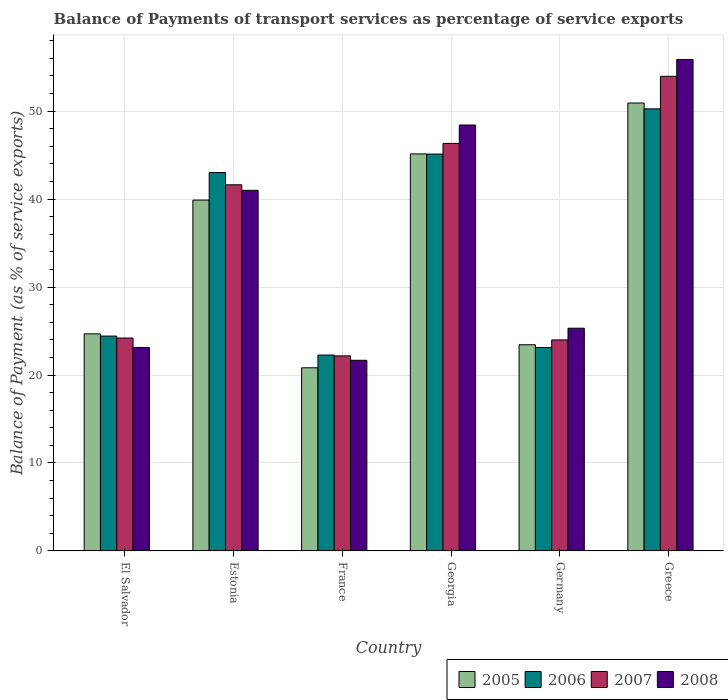How many different coloured bars are there?
Your answer should be compact. 4. Are the number of bars per tick equal to the number of legend labels?
Make the answer very short. Yes. How many bars are there on the 2nd tick from the left?
Provide a short and direct response. 4. How many bars are there on the 6th tick from the right?
Offer a terse response. 4. What is the label of the 3rd group of bars from the left?
Offer a terse response. France. What is the balance of payments of transport services in 2008 in El Salvador?
Your answer should be very brief. 23.13. Across all countries, what is the maximum balance of payments of transport services in 2008?
Provide a short and direct response. 55.87. Across all countries, what is the minimum balance of payments of transport services in 2006?
Make the answer very short. 22.27. What is the total balance of payments of transport services in 2005 in the graph?
Ensure brevity in your answer.  204.87. What is the difference between the balance of payments of transport services in 2005 in El Salvador and that in Greece?
Your response must be concise. -26.24. What is the difference between the balance of payments of transport services in 2005 in Georgia and the balance of payments of transport services in 2008 in El Salvador?
Keep it short and to the point. 22. What is the average balance of payments of transport services in 2005 per country?
Provide a short and direct response. 34.14. What is the difference between the balance of payments of transport services of/in 2006 and balance of payments of transport services of/in 2008 in Greece?
Your answer should be compact. -5.61. What is the ratio of the balance of payments of transport services in 2008 in El Salvador to that in Georgia?
Offer a very short reply. 0.48. Is the balance of payments of transport services in 2006 in El Salvador less than that in Greece?
Offer a terse response. Yes. What is the difference between the highest and the second highest balance of payments of transport services in 2005?
Offer a terse response. 5.78. What is the difference between the highest and the lowest balance of payments of transport services in 2008?
Provide a succinct answer. 34.19. Is the sum of the balance of payments of transport services in 2005 in Estonia and Greece greater than the maximum balance of payments of transport services in 2006 across all countries?
Make the answer very short. Yes. What does the 3rd bar from the left in Georgia represents?
Offer a terse response. 2007. What does the 2nd bar from the right in Georgia represents?
Offer a very short reply. 2007. Is it the case that in every country, the sum of the balance of payments of transport services in 2007 and balance of payments of transport services in 2006 is greater than the balance of payments of transport services in 2005?
Offer a terse response. Yes. How many bars are there?
Provide a succinct answer. 24. What is the difference between two consecutive major ticks on the Y-axis?
Your answer should be compact. 10. Where does the legend appear in the graph?
Keep it short and to the point. Bottom right. How many legend labels are there?
Offer a terse response. 4. What is the title of the graph?
Your answer should be very brief. Balance of Payments of transport services as percentage of service exports. Does "1997" appear as one of the legend labels in the graph?
Offer a terse response. No. What is the label or title of the Y-axis?
Provide a short and direct response. Balance of Payment (as % of service exports). What is the Balance of Payment (as % of service exports) in 2005 in El Salvador?
Offer a very short reply. 24.68. What is the Balance of Payment (as % of service exports) of 2006 in El Salvador?
Ensure brevity in your answer.  24.43. What is the Balance of Payment (as % of service exports) in 2007 in El Salvador?
Your answer should be very brief. 24.2. What is the Balance of Payment (as % of service exports) in 2008 in El Salvador?
Offer a terse response. 23.13. What is the Balance of Payment (as % of service exports) of 2005 in Estonia?
Give a very brief answer. 39.88. What is the Balance of Payment (as % of service exports) of 2006 in Estonia?
Ensure brevity in your answer.  43.01. What is the Balance of Payment (as % of service exports) in 2007 in Estonia?
Provide a succinct answer. 41.62. What is the Balance of Payment (as % of service exports) in 2008 in Estonia?
Your answer should be compact. 40.99. What is the Balance of Payment (as % of service exports) in 2005 in France?
Your answer should be very brief. 20.82. What is the Balance of Payment (as % of service exports) of 2006 in France?
Make the answer very short. 22.27. What is the Balance of Payment (as % of service exports) in 2007 in France?
Your answer should be compact. 22.18. What is the Balance of Payment (as % of service exports) in 2008 in France?
Your response must be concise. 21.67. What is the Balance of Payment (as % of service exports) in 2005 in Georgia?
Your answer should be compact. 45.13. What is the Balance of Payment (as % of service exports) of 2006 in Georgia?
Your response must be concise. 45.11. What is the Balance of Payment (as % of service exports) in 2007 in Georgia?
Ensure brevity in your answer.  46.33. What is the Balance of Payment (as % of service exports) in 2008 in Georgia?
Your response must be concise. 48.42. What is the Balance of Payment (as % of service exports) of 2005 in Germany?
Provide a short and direct response. 23.44. What is the Balance of Payment (as % of service exports) of 2006 in Germany?
Offer a very short reply. 23.13. What is the Balance of Payment (as % of service exports) in 2007 in Germany?
Offer a terse response. 23.99. What is the Balance of Payment (as % of service exports) in 2008 in Germany?
Provide a succinct answer. 25.32. What is the Balance of Payment (as % of service exports) in 2005 in Greece?
Provide a short and direct response. 50.92. What is the Balance of Payment (as % of service exports) in 2006 in Greece?
Your answer should be very brief. 50.25. What is the Balance of Payment (as % of service exports) in 2007 in Greece?
Your response must be concise. 53.95. What is the Balance of Payment (as % of service exports) of 2008 in Greece?
Provide a succinct answer. 55.87. Across all countries, what is the maximum Balance of Payment (as % of service exports) of 2005?
Ensure brevity in your answer.  50.92. Across all countries, what is the maximum Balance of Payment (as % of service exports) of 2006?
Your answer should be compact. 50.25. Across all countries, what is the maximum Balance of Payment (as % of service exports) of 2007?
Keep it short and to the point. 53.95. Across all countries, what is the maximum Balance of Payment (as % of service exports) in 2008?
Provide a short and direct response. 55.87. Across all countries, what is the minimum Balance of Payment (as % of service exports) of 2005?
Offer a terse response. 20.82. Across all countries, what is the minimum Balance of Payment (as % of service exports) of 2006?
Your answer should be very brief. 22.27. Across all countries, what is the minimum Balance of Payment (as % of service exports) of 2007?
Make the answer very short. 22.18. Across all countries, what is the minimum Balance of Payment (as % of service exports) in 2008?
Provide a succinct answer. 21.67. What is the total Balance of Payment (as % of service exports) of 2005 in the graph?
Your response must be concise. 204.87. What is the total Balance of Payment (as % of service exports) in 2006 in the graph?
Offer a very short reply. 208.2. What is the total Balance of Payment (as % of service exports) in 2007 in the graph?
Offer a terse response. 212.27. What is the total Balance of Payment (as % of service exports) of 2008 in the graph?
Your answer should be compact. 215.41. What is the difference between the Balance of Payment (as % of service exports) of 2005 in El Salvador and that in Estonia?
Keep it short and to the point. -15.21. What is the difference between the Balance of Payment (as % of service exports) in 2006 in El Salvador and that in Estonia?
Make the answer very short. -18.59. What is the difference between the Balance of Payment (as % of service exports) of 2007 in El Salvador and that in Estonia?
Your answer should be very brief. -17.42. What is the difference between the Balance of Payment (as % of service exports) in 2008 in El Salvador and that in Estonia?
Give a very brief answer. -17.86. What is the difference between the Balance of Payment (as % of service exports) in 2005 in El Salvador and that in France?
Your answer should be compact. 3.86. What is the difference between the Balance of Payment (as % of service exports) in 2006 in El Salvador and that in France?
Give a very brief answer. 2.16. What is the difference between the Balance of Payment (as % of service exports) in 2007 in El Salvador and that in France?
Your answer should be compact. 2.03. What is the difference between the Balance of Payment (as % of service exports) of 2008 in El Salvador and that in France?
Your answer should be very brief. 1.46. What is the difference between the Balance of Payment (as % of service exports) in 2005 in El Salvador and that in Georgia?
Your answer should be very brief. -20.45. What is the difference between the Balance of Payment (as % of service exports) in 2006 in El Salvador and that in Georgia?
Keep it short and to the point. -20.69. What is the difference between the Balance of Payment (as % of service exports) in 2007 in El Salvador and that in Georgia?
Offer a very short reply. -22.12. What is the difference between the Balance of Payment (as % of service exports) of 2008 in El Salvador and that in Georgia?
Make the answer very short. -25.28. What is the difference between the Balance of Payment (as % of service exports) in 2005 in El Salvador and that in Germany?
Make the answer very short. 1.24. What is the difference between the Balance of Payment (as % of service exports) of 2006 in El Salvador and that in Germany?
Provide a succinct answer. 1.3. What is the difference between the Balance of Payment (as % of service exports) of 2007 in El Salvador and that in Germany?
Offer a terse response. 0.21. What is the difference between the Balance of Payment (as % of service exports) of 2008 in El Salvador and that in Germany?
Provide a succinct answer. -2.19. What is the difference between the Balance of Payment (as % of service exports) in 2005 in El Salvador and that in Greece?
Ensure brevity in your answer.  -26.24. What is the difference between the Balance of Payment (as % of service exports) of 2006 in El Salvador and that in Greece?
Offer a terse response. -25.83. What is the difference between the Balance of Payment (as % of service exports) of 2007 in El Salvador and that in Greece?
Provide a succinct answer. -29.75. What is the difference between the Balance of Payment (as % of service exports) in 2008 in El Salvador and that in Greece?
Make the answer very short. -32.73. What is the difference between the Balance of Payment (as % of service exports) of 2005 in Estonia and that in France?
Offer a very short reply. 19.06. What is the difference between the Balance of Payment (as % of service exports) of 2006 in Estonia and that in France?
Give a very brief answer. 20.74. What is the difference between the Balance of Payment (as % of service exports) of 2007 in Estonia and that in France?
Provide a succinct answer. 19.45. What is the difference between the Balance of Payment (as % of service exports) of 2008 in Estonia and that in France?
Offer a terse response. 19.32. What is the difference between the Balance of Payment (as % of service exports) of 2005 in Estonia and that in Georgia?
Your response must be concise. -5.25. What is the difference between the Balance of Payment (as % of service exports) in 2006 in Estonia and that in Georgia?
Provide a short and direct response. -2.1. What is the difference between the Balance of Payment (as % of service exports) in 2007 in Estonia and that in Georgia?
Your answer should be compact. -4.7. What is the difference between the Balance of Payment (as % of service exports) in 2008 in Estonia and that in Georgia?
Your response must be concise. -7.42. What is the difference between the Balance of Payment (as % of service exports) of 2005 in Estonia and that in Germany?
Make the answer very short. 16.44. What is the difference between the Balance of Payment (as % of service exports) in 2006 in Estonia and that in Germany?
Keep it short and to the point. 19.89. What is the difference between the Balance of Payment (as % of service exports) in 2007 in Estonia and that in Germany?
Ensure brevity in your answer.  17.63. What is the difference between the Balance of Payment (as % of service exports) in 2008 in Estonia and that in Germany?
Your answer should be very brief. 15.67. What is the difference between the Balance of Payment (as % of service exports) in 2005 in Estonia and that in Greece?
Your response must be concise. -11.03. What is the difference between the Balance of Payment (as % of service exports) of 2006 in Estonia and that in Greece?
Give a very brief answer. -7.24. What is the difference between the Balance of Payment (as % of service exports) in 2007 in Estonia and that in Greece?
Make the answer very short. -12.33. What is the difference between the Balance of Payment (as % of service exports) of 2008 in Estonia and that in Greece?
Your answer should be very brief. -14.87. What is the difference between the Balance of Payment (as % of service exports) of 2005 in France and that in Georgia?
Make the answer very short. -24.31. What is the difference between the Balance of Payment (as % of service exports) of 2006 in France and that in Georgia?
Offer a terse response. -22.84. What is the difference between the Balance of Payment (as % of service exports) of 2007 in France and that in Georgia?
Ensure brevity in your answer.  -24.15. What is the difference between the Balance of Payment (as % of service exports) in 2008 in France and that in Georgia?
Your response must be concise. -26.74. What is the difference between the Balance of Payment (as % of service exports) in 2005 in France and that in Germany?
Your answer should be very brief. -2.62. What is the difference between the Balance of Payment (as % of service exports) in 2006 in France and that in Germany?
Keep it short and to the point. -0.86. What is the difference between the Balance of Payment (as % of service exports) in 2007 in France and that in Germany?
Your answer should be compact. -1.81. What is the difference between the Balance of Payment (as % of service exports) in 2008 in France and that in Germany?
Make the answer very short. -3.65. What is the difference between the Balance of Payment (as % of service exports) in 2005 in France and that in Greece?
Your answer should be very brief. -30.09. What is the difference between the Balance of Payment (as % of service exports) in 2006 in France and that in Greece?
Your answer should be very brief. -27.98. What is the difference between the Balance of Payment (as % of service exports) of 2007 in France and that in Greece?
Offer a terse response. -31.78. What is the difference between the Balance of Payment (as % of service exports) of 2008 in France and that in Greece?
Your answer should be compact. -34.19. What is the difference between the Balance of Payment (as % of service exports) in 2005 in Georgia and that in Germany?
Ensure brevity in your answer.  21.69. What is the difference between the Balance of Payment (as % of service exports) of 2006 in Georgia and that in Germany?
Keep it short and to the point. 21.99. What is the difference between the Balance of Payment (as % of service exports) in 2007 in Georgia and that in Germany?
Provide a succinct answer. 22.34. What is the difference between the Balance of Payment (as % of service exports) of 2008 in Georgia and that in Germany?
Your answer should be compact. 23.1. What is the difference between the Balance of Payment (as % of service exports) in 2005 in Georgia and that in Greece?
Ensure brevity in your answer.  -5.78. What is the difference between the Balance of Payment (as % of service exports) in 2006 in Georgia and that in Greece?
Ensure brevity in your answer.  -5.14. What is the difference between the Balance of Payment (as % of service exports) in 2007 in Georgia and that in Greece?
Give a very brief answer. -7.63. What is the difference between the Balance of Payment (as % of service exports) in 2008 in Georgia and that in Greece?
Provide a succinct answer. -7.45. What is the difference between the Balance of Payment (as % of service exports) in 2005 in Germany and that in Greece?
Provide a short and direct response. -27.48. What is the difference between the Balance of Payment (as % of service exports) in 2006 in Germany and that in Greece?
Your answer should be very brief. -27.13. What is the difference between the Balance of Payment (as % of service exports) of 2007 in Germany and that in Greece?
Provide a succinct answer. -29.96. What is the difference between the Balance of Payment (as % of service exports) of 2008 in Germany and that in Greece?
Keep it short and to the point. -30.55. What is the difference between the Balance of Payment (as % of service exports) of 2005 in El Salvador and the Balance of Payment (as % of service exports) of 2006 in Estonia?
Ensure brevity in your answer.  -18.33. What is the difference between the Balance of Payment (as % of service exports) in 2005 in El Salvador and the Balance of Payment (as % of service exports) in 2007 in Estonia?
Keep it short and to the point. -16.94. What is the difference between the Balance of Payment (as % of service exports) in 2005 in El Salvador and the Balance of Payment (as % of service exports) in 2008 in Estonia?
Your answer should be very brief. -16.32. What is the difference between the Balance of Payment (as % of service exports) in 2006 in El Salvador and the Balance of Payment (as % of service exports) in 2007 in Estonia?
Make the answer very short. -17.19. What is the difference between the Balance of Payment (as % of service exports) in 2006 in El Salvador and the Balance of Payment (as % of service exports) in 2008 in Estonia?
Provide a succinct answer. -16.57. What is the difference between the Balance of Payment (as % of service exports) of 2007 in El Salvador and the Balance of Payment (as % of service exports) of 2008 in Estonia?
Your response must be concise. -16.79. What is the difference between the Balance of Payment (as % of service exports) in 2005 in El Salvador and the Balance of Payment (as % of service exports) in 2006 in France?
Your response must be concise. 2.41. What is the difference between the Balance of Payment (as % of service exports) in 2005 in El Salvador and the Balance of Payment (as % of service exports) in 2007 in France?
Your response must be concise. 2.5. What is the difference between the Balance of Payment (as % of service exports) of 2005 in El Salvador and the Balance of Payment (as % of service exports) of 2008 in France?
Your answer should be compact. 3. What is the difference between the Balance of Payment (as % of service exports) of 2006 in El Salvador and the Balance of Payment (as % of service exports) of 2007 in France?
Offer a terse response. 2.25. What is the difference between the Balance of Payment (as % of service exports) of 2006 in El Salvador and the Balance of Payment (as % of service exports) of 2008 in France?
Your response must be concise. 2.75. What is the difference between the Balance of Payment (as % of service exports) of 2007 in El Salvador and the Balance of Payment (as % of service exports) of 2008 in France?
Offer a very short reply. 2.53. What is the difference between the Balance of Payment (as % of service exports) in 2005 in El Salvador and the Balance of Payment (as % of service exports) in 2006 in Georgia?
Provide a succinct answer. -20.44. What is the difference between the Balance of Payment (as % of service exports) in 2005 in El Salvador and the Balance of Payment (as % of service exports) in 2007 in Georgia?
Provide a succinct answer. -21.65. What is the difference between the Balance of Payment (as % of service exports) of 2005 in El Salvador and the Balance of Payment (as % of service exports) of 2008 in Georgia?
Offer a very short reply. -23.74. What is the difference between the Balance of Payment (as % of service exports) of 2006 in El Salvador and the Balance of Payment (as % of service exports) of 2007 in Georgia?
Your answer should be compact. -21.9. What is the difference between the Balance of Payment (as % of service exports) in 2006 in El Salvador and the Balance of Payment (as % of service exports) in 2008 in Georgia?
Your answer should be compact. -23.99. What is the difference between the Balance of Payment (as % of service exports) of 2007 in El Salvador and the Balance of Payment (as % of service exports) of 2008 in Georgia?
Keep it short and to the point. -24.21. What is the difference between the Balance of Payment (as % of service exports) in 2005 in El Salvador and the Balance of Payment (as % of service exports) in 2006 in Germany?
Offer a terse response. 1.55. What is the difference between the Balance of Payment (as % of service exports) in 2005 in El Salvador and the Balance of Payment (as % of service exports) in 2007 in Germany?
Offer a terse response. 0.69. What is the difference between the Balance of Payment (as % of service exports) in 2005 in El Salvador and the Balance of Payment (as % of service exports) in 2008 in Germany?
Keep it short and to the point. -0.64. What is the difference between the Balance of Payment (as % of service exports) in 2006 in El Salvador and the Balance of Payment (as % of service exports) in 2007 in Germany?
Provide a succinct answer. 0.44. What is the difference between the Balance of Payment (as % of service exports) of 2006 in El Salvador and the Balance of Payment (as % of service exports) of 2008 in Germany?
Your answer should be compact. -0.89. What is the difference between the Balance of Payment (as % of service exports) in 2007 in El Salvador and the Balance of Payment (as % of service exports) in 2008 in Germany?
Your answer should be compact. -1.12. What is the difference between the Balance of Payment (as % of service exports) in 2005 in El Salvador and the Balance of Payment (as % of service exports) in 2006 in Greece?
Your answer should be compact. -25.58. What is the difference between the Balance of Payment (as % of service exports) of 2005 in El Salvador and the Balance of Payment (as % of service exports) of 2007 in Greece?
Your answer should be very brief. -29.28. What is the difference between the Balance of Payment (as % of service exports) of 2005 in El Salvador and the Balance of Payment (as % of service exports) of 2008 in Greece?
Your response must be concise. -31.19. What is the difference between the Balance of Payment (as % of service exports) of 2006 in El Salvador and the Balance of Payment (as % of service exports) of 2007 in Greece?
Offer a terse response. -29.53. What is the difference between the Balance of Payment (as % of service exports) of 2006 in El Salvador and the Balance of Payment (as % of service exports) of 2008 in Greece?
Give a very brief answer. -31.44. What is the difference between the Balance of Payment (as % of service exports) of 2007 in El Salvador and the Balance of Payment (as % of service exports) of 2008 in Greece?
Provide a succinct answer. -31.66. What is the difference between the Balance of Payment (as % of service exports) in 2005 in Estonia and the Balance of Payment (as % of service exports) in 2006 in France?
Your response must be concise. 17.61. What is the difference between the Balance of Payment (as % of service exports) in 2005 in Estonia and the Balance of Payment (as % of service exports) in 2007 in France?
Your answer should be compact. 17.71. What is the difference between the Balance of Payment (as % of service exports) of 2005 in Estonia and the Balance of Payment (as % of service exports) of 2008 in France?
Offer a very short reply. 18.21. What is the difference between the Balance of Payment (as % of service exports) in 2006 in Estonia and the Balance of Payment (as % of service exports) in 2007 in France?
Give a very brief answer. 20.84. What is the difference between the Balance of Payment (as % of service exports) in 2006 in Estonia and the Balance of Payment (as % of service exports) in 2008 in France?
Provide a short and direct response. 21.34. What is the difference between the Balance of Payment (as % of service exports) in 2007 in Estonia and the Balance of Payment (as % of service exports) in 2008 in France?
Give a very brief answer. 19.95. What is the difference between the Balance of Payment (as % of service exports) of 2005 in Estonia and the Balance of Payment (as % of service exports) of 2006 in Georgia?
Make the answer very short. -5.23. What is the difference between the Balance of Payment (as % of service exports) in 2005 in Estonia and the Balance of Payment (as % of service exports) in 2007 in Georgia?
Keep it short and to the point. -6.44. What is the difference between the Balance of Payment (as % of service exports) in 2005 in Estonia and the Balance of Payment (as % of service exports) in 2008 in Georgia?
Ensure brevity in your answer.  -8.53. What is the difference between the Balance of Payment (as % of service exports) of 2006 in Estonia and the Balance of Payment (as % of service exports) of 2007 in Georgia?
Provide a succinct answer. -3.31. What is the difference between the Balance of Payment (as % of service exports) of 2006 in Estonia and the Balance of Payment (as % of service exports) of 2008 in Georgia?
Your answer should be compact. -5.4. What is the difference between the Balance of Payment (as % of service exports) in 2007 in Estonia and the Balance of Payment (as % of service exports) in 2008 in Georgia?
Keep it short and to the point. -6.8. What is the difference between the Balance of Payment (as % of service exports) in 2005 in Estonia and the Balance of Payment (as % of service exports) in 2006 in Germany?
Make the answer very short. 16.76. What is the difference between the Balance of Payment (as % of service exports) in 2005 in Estonia and the Balance of Payment (as % of service exports) in 2007 in Germany?
Offer a very short reply. 15.89. What is the difference between the Balance of Payment (as % of service exports) in 2005 in Estonia and the Balance of Payment (as % of service exports) in 2008 in Germany?
Your answer should be very brief. 14.56. What is the difference between the Balance of Payment (as % of service exports) of 2006 in Estonia and the Balance of Payment (as % of service exports) of 2007 in Germany?
Provide a succinct answer. 19.02. What is the difference between the Balance of Payment (as % of service exports) of 2006 in Estonia and the Balance of Payment (as % of service exports) of 2008 in Germany?
Your answer should be compact. 17.69. What is the difference between the Balance of Payment (as % of service exports) in 2007 in Estonia and the Balance of Payment (as % of service exports) in 2008 in Germany?
Give a very brief answer. 16.3. What is the difference between the Balance of Payment (as % of service exports) in 2005 in Estonia and the Balance of Payment (as % of service exports) in 2006 in Greece?
Your answer should be very brief. -10.37. What is the difference between the Balance of Payment (as % of service exports) of 2005 in Estonia and the Balance of Payment (as % of service exports) of 2007 in Greece?
Keep it short and to the point. -14.07. What is the difference between the Balance of Payment (as % of service exports) of 2005 in Estonia and the Balance of Payment (as % of service exports) of 2008 in Greece?
Your answer should be very brief. -15.98. What is the difference between the Balance of Payment (as % of service exports) of 2006 in Estonia and the Balance of Payment (as % of service exports) of 2007 in Greece?
Keep it short and to the point. -10.94. What is the difference between the Balance of Payment (as % of service exports) in 2006 in Estonia and the Balance of Payment (as % of service exports) in 2008 in Greece?
Offer a terse response. -12.86. What is the difference between the Balance of Payment (as % of service exports) of 2007 in Estonia and the Balance of Payment (as % of service exports) of 2008 in Greece?
Your answer should be very brief. -14.25. What is the difference between the Balance of Payment (as % of service exports) of 2005 in France and the Balance of Payment (as % of service exports) of 2006 in Georgia?
Your response must be concise. -24.29. What is the difference between the Balance of Payment (as % of service exports) in 2005 in France and the Balance of Payment (as % of service exports) in 2007 in Georgia?
Offer a very short reply. -25.5. What is the difference between the Balance of Payment (as % of service exports) of 2005 in France and the Balance of Payment (as % of service exports) of 2008 in Georgia?
Offer a very short reply. -27.6. What is the difference between the Balance of Payment (as % of service exports) of 2006 in France and the Balance of Payment (as % of service exports) of 2007 in Georgia?
Your answer should be very brief. -24.06. What is the difference between the Balance of Payment (as % of service exports) in 2006 in France and the Balance of Payment (as % of service exports) in 2008 in Georgia?
Your answer should be compact. -26.15. What is the difference between the Balance of Payment (as % of service exports) of 2007 in France and the Balance of Payment (as % of service exports) of 2008 in Georgia?
Offer a very short reply. -26.24. What is the difference between the Balance of Payment (as % of service exports) in 2005 in France and the Balance of Payment (as % of service exports) in 2006 in Germany?
Give a very brief answer. -2.31. What is the difference between the Balance of Payment (as % of service exports) of 2005 in France and the Balance of Payment (as % of service exports) of 2007 in Germany?
Keep it short and to the point. -3.17. What is the difference between the Balance of Payment (as % of service exports) in 2005 in France and the Balance of Payment (as % of service exports) in 2008 in Germany?
Ensure brevity in your answer.  -4.5. What is the difference between the Balance of Payment (as % of service exports) of 2006 in France and the Balance of Payment (as % of service exports) of 2007 in Germany?
Keep it short and to the point. -1.72. What is the difference between the Balance of Payment (as % of service exports) in 2006 in France and the Balance of Payment (as % of service exports) in 2008 in Germany?
Keep it short and to the point. -3.05. What is the difference between the Balance of Payment (as % of service exports) of 2007 in France and the Balance of Payment (as % of service exports) of 2008 in Germany?
Your answer should be compact. -3.14. What is the difference between the Balance of Payment (as % of service exports) in 2005 in France and the Balance of Payment (as % of service exports) in 2006 in Greece?
Your answer should be very brief. -29.43. What is the difference between the Balance of Payment (as % of service exports) of 2005 in France and the Balance of Payment (as % of service exports) of 2007 in Greece?
Give a very brief answer. -33.13. What is the difference between the Balance of Payment (as % of service exports) in 2005 in France and the Balance of Payment (as % of service exports) in 2008 in Greece?
Offer a very short reply. -35.05. What is the difference between the Balance of Payment (as % of service exports) of 2006 in France and the Balance of Payment (as % of service exports) of 2007 in Greece?
Give a very brief answer. -31.68. What is the difference between the Balance of Payment (as % of service exports) of 2006 in France and the Balance of Payment (as % of service exports) of 2008 in Greece?
Your response must be concise. -33.6. What is the difference between the Balance of Payment (as % of service exports) of 2007 in France and the Balance of Payment (as % of service exports) of 2008 in Greece?
Your response must be concise. -33.69. What is the difference between the Balance of Payment (as % of service exports) in 2005 in Georgia and the Balance of Payment (as % of service exports) in 2006 in Germany?
Provide a succinct answer. 22. What is the difference between the Balance of Payment (as % of service exports) of 2005 in Georgia and the Balance of Payment (as % of service exports) of 2007 in Germany?
Keep it short and to the point. 21.14. What is the difference between the Balance of Payment (as % of service exports) of 2005 in Georgia and the Balance of Payment (as % of service exports) of 2008 in Germany?
Provide a succinct answer. 19.81. What is the difference between the Balance of Payment (as % of service exports) of 2006 in Georgia and the Balance of Payment (as % of service exports) of 2007 in Germany?
Your answer should be very brief. 21.12. What is the difference between the Balance of Payment (as % of service exports) in 2006 in Georgia and the Balance of Payment (as % of service exports) in 2008 in Germany?
Make the answer very short. 19.79. What is the difference between the Balance of Payment (as % of service exports) in 2007 in Georgia and the Balance of Payment (as % of service exports) in 2008 in Germany?
Provide a succinct answer. 21.01. What is the difference between the Balance of Payment (as % of service exports) of 2005 in Georgia and the Balance of Payment (as % of service exports) of 2006 in Greece?
Your answer should be very brief. -5.12. What is the difference between the Balance of Payment (as % of service exports) in 2005 in Georgia and the Balance of Payment (as % of service exports) in 2007 in Greece?
Your response must be concise. -8.82. What is the difference between the Balance of Payment (as % of service exports) of 2005 in Georgia and the Balance of Payment (as % of service exports) of 2008 in Greece?
Your answer should be compact. -10.74. What is the difference between the Balance of Payment (as % of service exports) in 2006 in Georgia and the Balance of Payment (as % of service exports) in 2007 in Greece?
Ensure brevity in your answer.  -8.84. What is the difference between the Balance of Payment (as % of service exports) of 2006 in Georgia and the Balance of Payment (as % of service exports) of 2008 in Greece?
Offer a terse response. -10.75. What is the difference between the Balance of Payment (as % of service exports) of 2007 in Georgia and the Balance of Payment (as % of service exports) of 2008 in Greece?
Offer a very short reply. -9.54. What is the difference between the Balance of Payment (as % of service exports) of 2005 in Germany and the Balance of Payment (as % of service exports) of 2006 in Greece?
Provide a succinct answer. -26.81. What is the difference between the Balance of Payment (as % of service exports) in 2005 in Germany and the Balance of Payment (as % of service exports) in 2007 in Greece?
Offer a very short reply. -30.51. What is the difference between the Balance of Payment (as % of service exports) of 2005 in Germany and the Balance of Payment (as % of service exports) of 2008 in Greece?
Provide a short and direct response. -32.43. What is the difference between the Balance of Payment (as % of service exports) of 2006 in Germany and the Balance of Payment (as % of service exports) of 2007 in Greece?
Give a very brief answer. -30.83. What is the difference between the Balance of Payment (as % of service exports) of 2006 in Germany and the Balance of Payment (as % of service exports) of 2008 in Greece?
Offer a terse response. -32.74. What is the difference between the Balance of Payment (as % of service exports) of 2007 in Germany and the Balance of Payment (as % of service exports) of 2008 in Greece?
Give a very brief answer. -31.88. What is the average Balance of Payment (as % of service exports) of 2005 per country?
Keep it short and to the point. 34.14. What is the average Balance of Payment (as % of service exports) of 2006 per country?
Ensure brevity in your answer.  34.7. What is the average Balance of Payment (as % of service exports) of 2007 per country?
Provide a short and direct response. 35.38. What is the average Balance of Payment (as % of service exports) in 2008 per country?
Ensure brevity in your answer.  35.9. What is the difference between the Balance of Payment (as % of service exports) of 2005 and Balance of Payment (as % of service exports) of 2006 in El Salvador?
Make the answer very short. 0.25. What is the difference between the Balance of Payment (as % of service exports) of 2005 and Balance of Payment (as % of service exports) of 2007 in El Salvador?
Provide a short and direct response. 0.47. What is the difference between the Balance of Payment (as % of service exports) in 2005 and Balance of Payment (as % of service exports) in 2008 in El Salvador?
Your response must be concise. 1.54. What is the difference between the Balance of Payment (as % of service exports) in 2006 and Balance of Payment (as % of service exports) in 2007 in El Salvador?
Give a very brief answer. 0.22. What is the difference between the Balance of Payment (as % of service exports) in 2006 and Balance of Payment (as % of service exports) in 2008 in El Salvador?
Keep it short and to the point. 1.29. What is the difference between the Balance of Payment (as % of service exports) in 2007 and Balance of Payment (as % of service exports) in 2008 in El Salvador?
Give a very brief answer. 1.07. What is the difference between the Balance of Payment (as % of service exports) in 2005 and Balance of Payment (as % of service exports) in 2006 in Estonia?
Your answer should be compact. -3.13. What is the difference between the Balance of Payment (as % of service exports) of 2005 and Balance of Payment (as % of service exports) of 2007 in Estonia?
Your answer should be compact. -1.74. What is the difference between the Balance of Payment (as % of service exports) of 2005 and Balance of Payment (as % of service exports) of 2008 in Estonia?
Offer a very short reply. -1.11. What is the difference between the Balance of Payment (as % of service exports) of 2006 and Balance of Payment (as % of service exports) of 2007 in Estonia?
Offer a very short reply. 1.39. What is the difference between the Balance of Payment (as % of service exports) in 2006 and Balance of Payment (as % of service exports) in 2008 in Estonia?
Provide a succinct answer. 2.02. What is the difference between the Balance of Payment (as % of service exports) in 2007 and Balance of Payment (as % of service exports) in 2008 in Estonia?
Keep it short and to the point. 0.63. What is the difference between the Balance of Payment (as % of service exports) in 2005 and Balance of Payment (as % of service exports) in 2006 in France?
Offer a terse response. -1.45. What is the difference between the Balance of Payment (as % of service exports) in 2005 and Balance of Payment (as % of service exports) in 2007 in France?
Your answer should be very brief. -1.35. What is the difference between the Balance of Payment (as % of service exports) in 2005 and Balance of Payment (as % of service exports) in 2008 in France?
Offer a terse response. -0.85. What is the difference between the Balance of Payment (as % of service exports) in 2006 and Balance of Payment (as % of service exports) in 2007 in France?
Make the answer very short. 0.09. What is the difference between the Balance of Payment (as % of service exports) in 2006 and Balance of Payment (as % of service exports) in 2008 in France?
Your answer should be very brief. 0.6. What is the difference between the Balance of Payment (as % of service exports) in 2007 and Balance of Payment (as % of service exports) in 2008 in France?
Offer a terse response. 0.5. What is the difference between the Balance of Payment (as % of service exports) in 2005 and Balance of Payment (as % of service exports) in 2006 in Georgia?
Provide a succinct answer. 0.02. What is the difference between the Balance of Payment (as % of service exports) of 2005 and Balance of Payment (as % of service exports) of 2007 in Georgia?
Offer a terse response. -1.2. What is the difference between the Balance of Payment (as % of service exports) in 2005 and Balance of Payment (as % of service exports) in 2008 in Georgia?
Your answer should be very brief. -3.29. What is the difference between the Balance of Payment (as % of service exports) of 2006 and Balance of Payment (as % of service exports) of 2007 in Georgia?
Ensure brevity in your answer.  -1.21. What is the difference between the Balance of Payment (as % of service exports) of 2006 and Balance of Payment (as % of service exports) of 2008 in Georgia?
Offer a very short reply. -3.3. What is the difference between the Balance of Payment (as % of service exports) in 2007 and Balance of Payment (as % of service exports) in 2008 in Georgia?
Your answer should be compact. -2.09. What is the difference between the Balance of Payment (as % of service exports) of 2005 and Balance of Payment (as % of service exports) of 2006 in Germany?
Ensure brevity in your answer.  0.31. What is the difference between the Balance of Payment (as % of service exports) of 2005 and Balance of Payment (as % of service exports) of 2007 in Germany?
Provide a short and direct response. -0.55. What is the difference between the Balance of Payment (as % of service exports) of 2005 and Balance of Payment (as % of service exports) of 2008 in Germany?
Ensure brevity in your answer.  -1.88. What is the difference between the Balance of Payment (as % of service exports) in 2006 and Balance of Payment (as % of service exports) in 2007 in Germany?
Offer a terse response. -0.86. What is the difference between the Balance of Payment (as % of service exports) in 2006 and Balance of Payment (as % of service exports) in 2008 in Germany?
Give a very brief answer. -2.19. What is the difference between the Balance of Payment (as % of service exports) in 2007 and Balance of Payment (as % of service exports) in 2008 in Germany?
Your answer should be compact. -1.33. What is the difference between the Balance of Payment (as % of service exports) in 2005 and Balance of Payment (as % of service exports) in 2006 in Greece?
Your answer should be compact. 0.66. What is the difference between the Balance of Payment (as % of service exports) in 2005 and Balance of Payment (as % of service exports) in 2007 in Greece?
Provide a succinct answer. -3.04. What is the difference between the Balance of Payment (as % of service exports) in 2005 and Balance of Payment (as % of service exports) in 2008 in Greece?
Provide a short and direct response. -4.95. What is the difference between the Balance of Payment (as % of service exports) of 2006 and Balance of Payment (as % of service exports) of 2007 in Greece?
Keep it short and to the point. -3.7. What is the difference between the Balance of Payment (as % of service exports) of 2006 and Balance of Payment (as % of service exports) of 2008 in Greece?
Ensure brevity in your answer.  -5.61. What is the difference between the Balance of Payment (as % of service exports) of 2007 and Balance of Payment (as % of service exports) of 2008 in Greece?
Provide a succinct answer. -1.92. What is the ratio of the Balance of Payment (as % of service exports) of 2005 in El Salvador to that in Estonia?
Your answer should be compact. 0.62. What is the ratio of the Balance of Payment (as % of service exports) in 2006 in El Salvador to that in Estonia?
Offer a terse response. 0.57. What is the ratio of the Balance of Payment (as % of service exports) in 2007 in El Salvador to that in Estonia?
Your answer should be very brief. 0.58. What is the ratio of the Balance of Payment (as % of service exports) in 2008 in El Salvador to that in Estonia?
Offer a terse response. 0.56. What is the ratio of the Balance of Payment (as % of service exports) of 2005 in El Salvador to that in France?
Provide a succinct answer. 1.19. What is the ratio of the Balance of Payment (as % of service exports) of 2006 in El Salvador to that in France?
Provide a short and direct response. 1.1. What is the ratio of the Balance of Payment (as % of service exports) in 2007 in El Salvador to that in France?
Provide a succinct answer. 1.09. What is the ratio of the Balance of Payment (as % of service exports) in 2008 in El Salvador to that in France?
Keep it short and to the point. 1.07. What is the ratio of the Balance of Payment (as % of service exports) of 2005 in El Salvador to that in Georgia?
Your answer should be very brief. 0.55. What is the ratio of the Balance of Payment (as % of service exports) of 2006 in El Salvador to that in Georgia?
Give a very brief answer. 0.54. What is the ratio of the Balance of Payment (as % of service exports) of 2007 in El Salvador to that in Georgia?
Offer a very short reply. 0.52. What is the ratio of the Balance of Payment (as % of service exports) of 2008 in El Salvador to that in Georgia?
Your response must be concise. 0.48. What is the ratio of the Balance of Payment (as % of service exports) in 2005 in El Salvador to that in Germany?
Make the answer very short. 1.05. What is the ratio of the Balance of Payment (as % of service exports) in 2006 in El Salvador to that in Germany?
Make the answer very short. 1.06. What is the ratio of the Balance of Payment (as % of service exports) in 2007 in El Salvador to that in Germany?
Keep it short and to the point. 1.01. What is the ratio of the Balance of Payment (as % of service exports) in 2008 in El Salvador to that in Germany?
Keep it short and to the point. 0.91. What is the ratio of the Balance of Payment (as % of service exports) of 2005 in El Salvador to that in Greece?
Your response must be concise. 0.48. What is the ratio of the Balance of Payment (as % of service exports) of 2006 in El Salvador to that in Greece?
Your response must be concise. 0.49. What is the ratio of the Balance of Payment (as % of service exports) in 2007 in El Salvador to that in Greece?
Your answer should be very brief. 0.45. What is the ratio of the Balance of Payment (as % of service exports) of 2008 in El Salvador to that in Greece?
Ensure brevity in your answer.  0.41. What is the ratio of the Balance of Payment (as % of service exports) of 2005 in Estonia to that in France?
Provide a short and direct response. 1.92. What is the ratio of the Balance of Payment (as % of service exports) of 2006 in Estonia to that in France?
Make the answer very short. 1.93. What is the ratio of the Balance of Payment (as % of service exports) in 2007 in Estonia to that in France?
Offer a terse response. 1.88. What is the ratio of the Balance of Payment (as % of service exports) in 2008 in Estonia to that in France?
Provide a short and direct response. 1.89. What is the ratio of the Balance of Payment (as % of service exports) of 2005 in Estonia to that in Georgia?
Provide a succinct answer. 0.88. What is the ratio of the Balance of Payment (as % of service exports) in 2006 in Estonia to that in Georgia?
Ensure brevity in your answer.  0.95. What is the ratio of the Balance of Payment (as % of service exports) in 2007 in Estonia to that in Georgia?
Your answer should be very brief. 0.9. What is the ratio of the Balance of Payment (as % of service exports) of 2008 in Estonia to that in Georgia?
Make the answer very short. 0.85. What is the ratio of the Balance of Payment (as % of service exports) in 2005 in Estonia to that in Germany?
Offer a very short reply. 1.7. What is the ratio of the Balance of Payment (as % of service exports) in 2006 in Estonia to that in Germany?
Make the answer very short. 1.86. What is the ratio of the Balance of Payment (as % of service exports) of 2007 in Estonia to that in Germany?
Offer a very short reply. 1.73. What is the ratio of the Balance of Payment (as % of service exports) of 2008 in Estonia to that in Germany?
Your response must be concise. 1.62. What is the ratio of the Balance of Payment (as % of service exports) of 2005 in Estonia to that in Greece?
Offer a very short reply. 0.78. What is the ratio of the Balance of Payment (as % of service exports) in 2006 in Estonia to that in Greece?
Your response must be concise. 0.86. What is the ratio of the Balance of Payment (as % of service exports) in 2007 in Estonia to that in Greece?
Your answer should be compact. 0.77. What is the ratio of the Balance of Payment (as % of service exports) in 2008 in Estonia to that in Greece?
Offer a terse response. 0.73. What is the ratio of the Balance of Payment (as % of service exports) of 2005 in France to that in Georgia?
Keep it short and to the point. 0.46. What is the ratio of the Balance of Payment (as % of service exports) in 2006 in France to that in Georgia?
Ensure brevity in your answer.  0.49. What is the ratio of the Balance of Payment (as % of service exports) of 2007 in France to that in Georgia?
Provide a short and direct response. 0.48. What is the ratio of the Balance of Payment (as % of service exports) in 2008 in France to that in Georgia?
Ensure brevity in your answer.  0.45. What is the ratio of the Balance of Payment (as % of service exports) of 2005 in France to that in Germany?
Offer a very short reply. 0.89. What is the ratio of the Balance of Payment (as % of service exports) in 2006 in France to that in Germany?
Provide a short and direct response. 0.96. What is the ratio of the Balance of Payment (as % of service exports) of 2007 in France to that in Germany?
Offer a very short reply. 0.92. What is the ratio of the Balance of Payment (as % of service exports) in 2008 in France to that in Germany?
Your response must be concise. 0.86. What is the ratio of the Balance of Payment (as % of service exports) in 2005 in France to that in Greece?
Keep it short and to the point. 0.41. What is the ratio of the Balance of Payment (as % of service exports) of 2006 in France to that in Greece?
Offer a terse response. 0.44. What is the ratio of the Balance of Payment (as % of service exports) in 2007 in France to that in Greece?
Keep it short and to the point. 0.41. What is the ratio of the Balance of Payment (as % of service exports) of 2008 in France to that in Greece?
Your answer should be compact. 0.39. What is the ratio of the Balance of Payment (as % of service exports) in 2005 in Georgia to that in Germany?
Offer a very short reply. 1.93. What is the ratio of the Balance of Payment (as % of service exports) in 2006 in Georgia to that in Germany?
Your response must be concise. 1.95. What is the ratio of the Balance of Payment (as % of service exports) of 2007 in Georgia to that in Germany?
Your answer should be compact. 1.93. What is the ratio of the Balance of Payment (as % of service exports) in 2008 in Georgia to that in Germany?
Give a very brief answer. 1.91. What is the ratio of the Balance of Payment (as % of service exports) of 2005 in Georgia to that in Greece?
Make the answer very short. 0.89. What is the ratio of the Balance of Payment (as % of service exports) of 2006 in Georgia to that in Greece?
Your answer should be very brief. 0.9. What is the ratio of the Balance of Payment (as % of service exports) of 2007 in Georgia to that in Greece?
Your answer should be very brief. 0.86. What is the ratio of the Balance of Payment (as % of service exports) in 2008 in Georgia to that in Greece?
Keep it short and to the point. 0.87. What is the ratio of the Balance of Payment (as % of service exports) of 2005 in Germany to that in Greece?
Your answer should be compact. 0.46. What is the ratio of the Balance of Payment (as % of service exports) in 2006 in Germany to that in Greece?
Provide a short and direct response. 0.46. What is the ratio of the Balance of Payment (as % of service exports) in 2007 in Germany to that in Greece?
Offer a terse response. 0.44. What is the ratio of the Balance of Payment (as % of service exports) in 2008 in Germany to that in Greece?
Give a very brief answer. 0.45. What is the difference between the highest and the second highest Balance of Payment (as % of service exports) of 2005?
Offer a terse response. 5.78. What is the difference between the highest and the second highest Balance of Payment (as % of service exports) of 2006?
Make the answer very short. 5.14. What is the difference between the highest and the second highest Balance of Payment (as % of service exports) in 2007?
Your response must be concise. 7.63. What is the difference between the highest and the second highest Balance of Payment (as % of service exports) of 2008?
Your answer should be very brief. 7.45. What is the difference between the highest and the lowest Balance of Payment (as % of service exports) of 2005?
Keep it short and to the point. 30.09. What is the difference between the highest and the lowest Balance of Payment (as % of service exports) of 2006?
Ensure brevity in your answer.  27.98. What is the difference between the highest and the lowest Balance of Payment (as % of service exports) of 2007?
Keep it short and to the point. 31.78. What is the difference between the highest and the lowest Balance of Payment (as % of service exports) in 2008?
Provide a succinct answer. 34.19. 